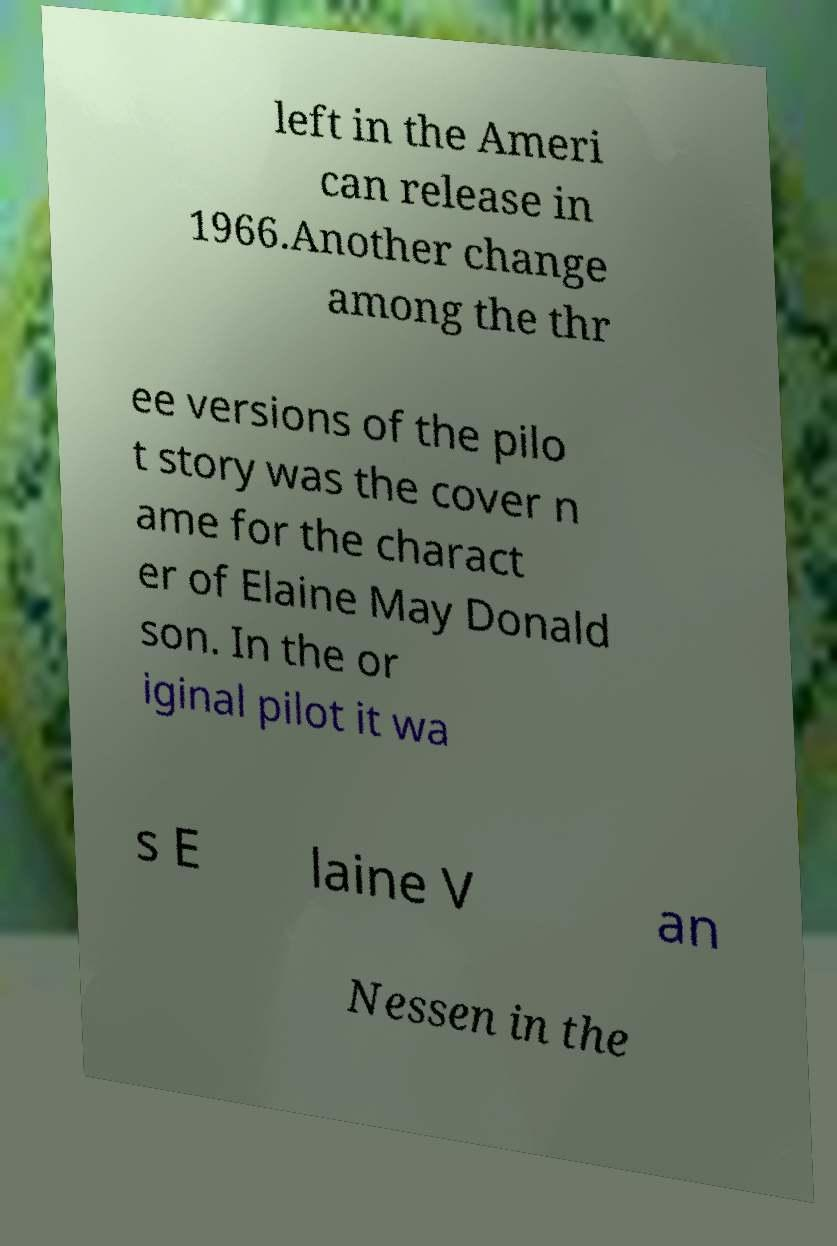Could you extract and type out the text from this image? left in the Ameri can release in 1966.Another change among the thr ee versions of the pilo t story was the cover n ame for the charact er of Elaine May Donald son. In the or iginal pilot it wa s E laine V an Nessen in the 